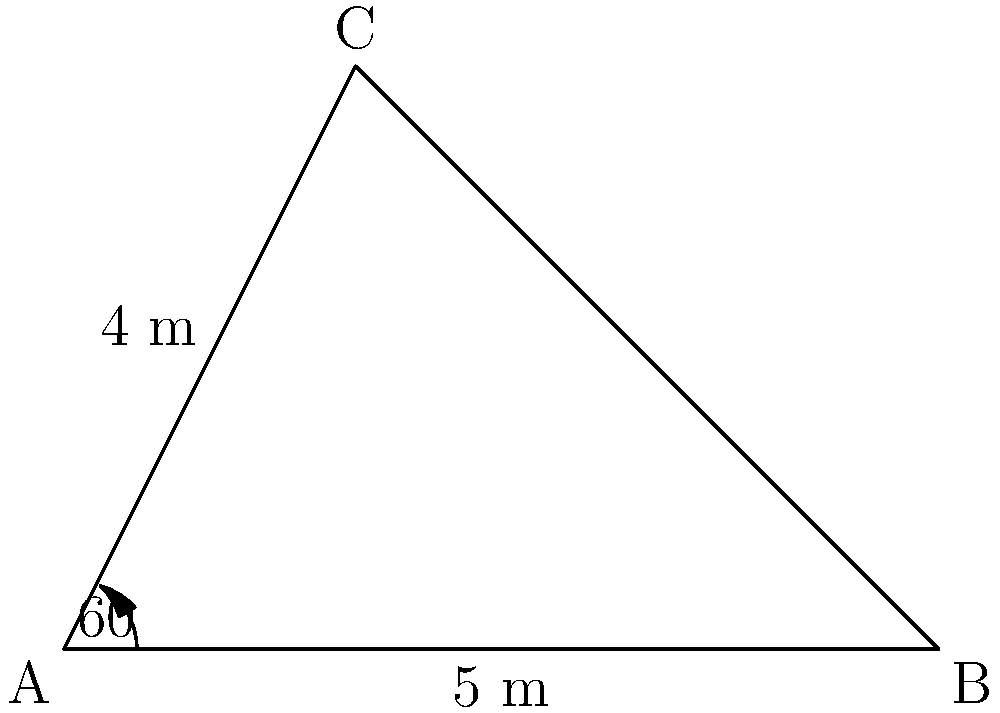An ancient Egyptian boat has a triangular sail. Two sides of the sail measure 4 m and 5 m, with an angle of 60° between them. Calculate the area of the sail in square meters. Round your answer to two decimal places. To find the area of the triangular sail, we can use the formula for the area of a triangle given two sides and the included angle:

$$A = \frac{1}{2} ab \sin C$$

Where:
$A$ is the area of the triangle
$a$ and $b$ are the two known sides
$C$ is the angle between these sides

Given:
$a = 4$ m
$b = 5$ m
$C = 60°$

Step 1: Substitute the values into the formula:
$$A = \frac{1}{2} \cdot 4 \cdot 5 \cdot \sin 60°$$

Step 2: Calculate $\sin 60°$:
$\sin 60° = \frac{\sqrt{3}}{2} \approx 0.8660$

Step 3: Substitute this value and calculate:
$$A = \frac{1}{2} \cdot 4 \cdot 5 \cdot 0.8660$$
$$A = 10 \cdot 0.8660 = 8.66$$

Step 4: Round to two decimal places:
$A \approx 8.66$ m²

Therefore, the area of the triangular sail is approximately 8.66 square meters.
Answer: 8.66 m² 